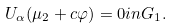<formula> <loc_0><loc_0><loc_500><loc_500>U _ { \alpha } ( \mu _ { 2 } + c \varphi ) = 0 i n G _ { 1 } .</formula> 